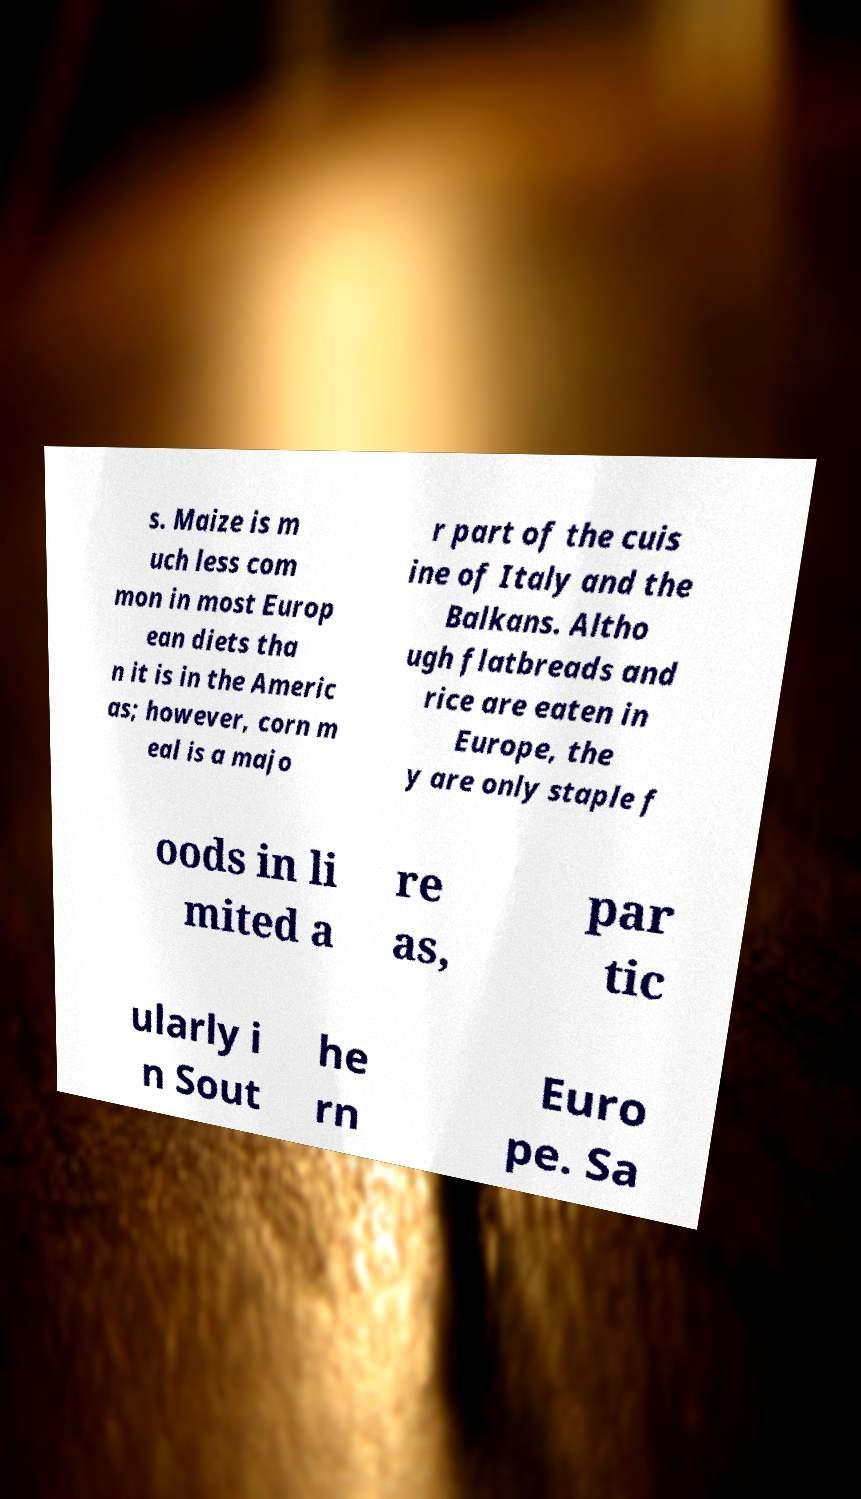What messages or text are displayed in this image? I need them in a readable, typed format. s. Maize is m uch less com mon in most Europ ean diets tha n it is in the Americ as; however, corn m eal is a majo r part of the cuis ine of Italy and the Balkans. Altho ugh flatbreads and rice are eaten in Europe, the y are only staple f oods in li mited a re as, par tic ularly i n Sout he rn Euro pe. Sa 